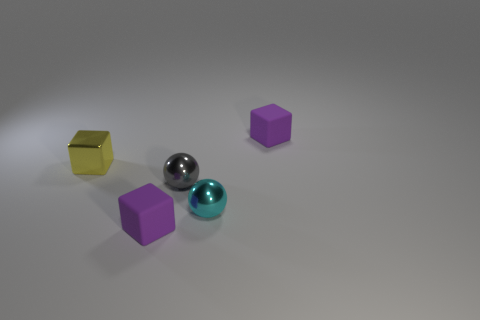How many objects are either tiny purple rubber blocks that are in front of the tiny gray metallic sphere or tiny blue matte spheres?
Give a very brief answer. 1. Is the number of small cyan spheres that are in front of the small cyan metallic thing the same as the number of small gray things behind the yellow block?
Keep it short and to the point. Yes. The purple thing that is on the right side of the small purple rubber block that is in front of the small purple cube that is behind the gray metal object is made of what material?
Keep it short and to the point. Rubber. Do the gray thing and the small cyan shiny object have the same shape?
Give a very brief answer. Yes. There is a small yellow object that is made of the same material as the tiny gray sphere; what is its shape?
Give a very brief answer. Cube. What number of tiny things are blocks or purple rubber things?
Make the answer very short. 3. Is there a matte cube on the right side of the tiny matte cube that is behind the tiny yellow shiny block?
Your answer should be compact. No. Are any tiny cyan metallic spheres visible?
Your answer should be compact. Yes. There is a rubber block on the left side of the matte cube behind the cyan ball; what color is it?
Offer a very short reply. Purple. How many purple matte blocks have the same size as the metallic cube?
Offer a very short reply. 2. 